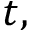Convert formula to latex. <formula><loc_0><loc_0><loc_500><loc_500>t ,</formula> 